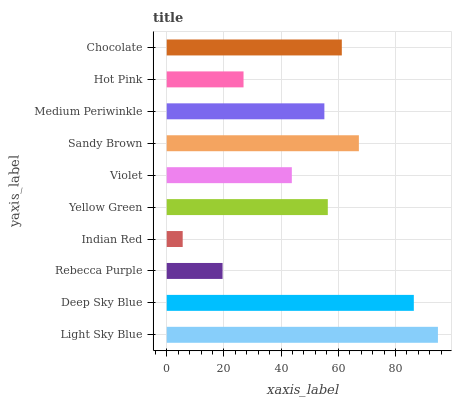Is Indian Red the minimum?
Answer yes or no. Yes. Is Light Sky Blue the maximum?
Answer yes or no. Yes. Is Deep Sky Blue the minimum?
Answer yes or no. No. Is Deep Sky Blue the maximum?
Answer yes or no. No. Is Light Sky Blue greater than Deep Sky Blue?
Answer yes or no. Yes. Is Deep Sky Blue less than Light Sky Blue?
Answer yes or no. Yes. Is Deep Sky Blue greater than Light Sky Blue?
Answer yes or no. No. Is Light Sky Blue less than Deep Sky Blue?
Answer yes or no. No. Is Yellow Green the high median?
Answer yes or no. Yes. Is Medium Periwinkle the low median?
Answer yes or no. Yes. Is Deep Sky Blue the high median?
Answer yes or no. No. Is Indian Red the low median?
Answer yes or no. No. 